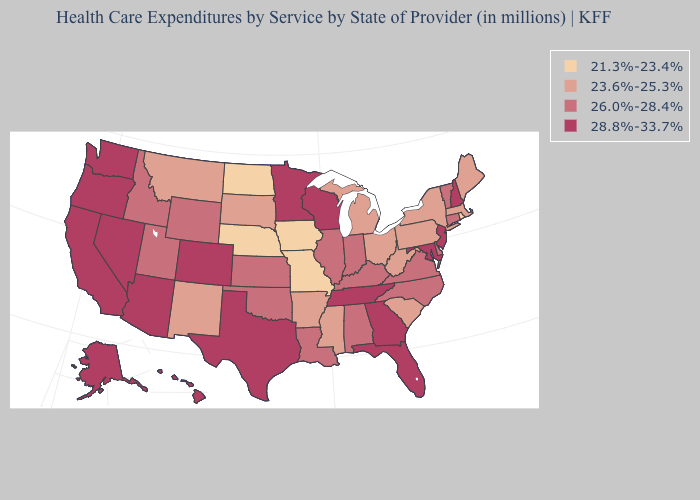How many symbols are there in the legend?
Be succinct. 4. Name the states that have a value in the range 23.6%-25.3%?
Answer briefly. Arkansas, Maine, Massachusetts, Michigan, Mississippi, Montana, New Mexico, New York, Ohio, Pennsylvania, South Carolina, South Dakota, West Virginia. What is the value of Louisiana?
Give a very brief answer. 26.0%-28.4%. Among the states that border California , which have the highest value?
Write a very short answer. Arizona, Nevada, Oregon. Name the states that have a value in the range 28.8%-33.7%?
Concise answer only. Alaska, Arizona, California, Colorado, Florida, Georgia, Hawaii, Maryland, Minnesota, Nevada, New Hampshire, New Jersey, Oregon, Tennessee, Texas, Washington, Wisconsin. Does the map have missing data?
Keep it brief. No. Does New York have the highest value in the Northeast?
Give a very brief answer. No. Name the states that have a value in the range 21.3%-23.4%?
Concise answer only. Iowa, Missouri, Nebraska, North Dakota, Rhode Island. Does Virginia have a lower value than New Hampshire?
Answer briefly. Yes. Among the states that border Virginia , which have the lowest value?
Be succinct. West Virginia. What is the lowest value in states that border New Jersey?
Quick response, please. 23.6%-25.3%. What is the value of Maryland?
Write a very short answer. 28.8%-33.7%. What is the value of New Hampshire?
Give a very brief answer. 28.8%-33.7%. What is the highest value in the USA?
Be succinct. 28.8%-33.7%. 